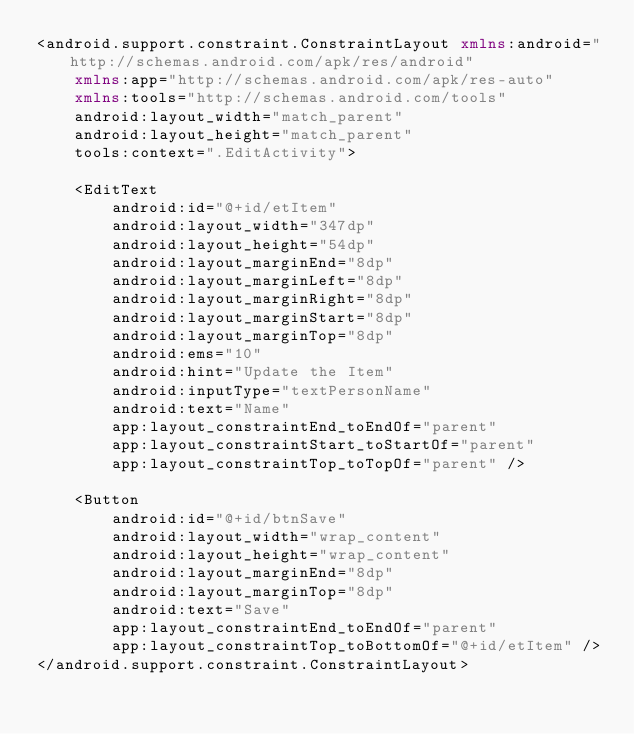Convert code to text. <code><loc_0><loc_0><loc_500><loc_500><_XML_><android.support.constraint.ConstraintLayout xmlns:android="http://schemas.android.com/apk/res/android"
    xmlns:app="http://schemas.android.com/apk/res-auto"
    xmlns:tools="http://schemas.android.com/tools"
    android:layout_width="match_parent"
    android:layout_height="match_parent"
    tools:context=".EditActivity">

    <EditText
        android:id="@+id/etItem"
        android:layout_width="347dp"
        android:layout_height="54dp"
        android:layout_marginEnd="8dp"
        android:layout_marginLeft="8dp"
        android:layout_marginRight="8dp"
        android:layout_marginStart="8dp"
        android:layout_marginTop="8dp"
        android:ems="10"
        android:hint="Update the Item"
        android:inputType="textPersonName"
        android:text="Name"
        app:layout_constraintEnd_toEndOf="parent"
        app:layout_constraintStart_toStartOf="parent"
        app:layout_constraintTop_toTopOf="parent" />

    <Button
        android:id="@+id/btnSave"
        android:layout_width="wrap_content"
        android:layout_height="wrap_content"
        android:layout_marginEnd="8dp"
        android:layout_marginTop="8dp"
        android:text="Save"
        app:layout_constraintEnd_toEndOf="parent"
        app:layout_constraintTop_toBottomOf="@+id/etItem" />
</android.support.constraint.ConstraintLayout></code> 